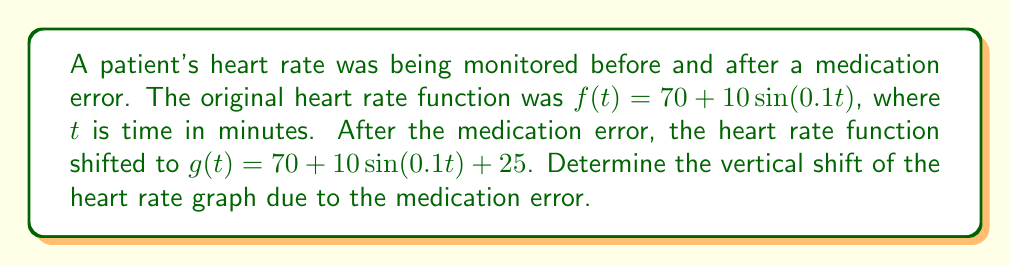What is the answer to this math problem? To find the vertical shift, we need to compare the two functions:

1) Original function: $f(t) = 70 + 10\sin(0.1t)$
2) Shifted function: $g(t) = 70 + 10\sin(0.1t) + 25$

The general form of a vertical shift is:

$g(t) = f(t) + k$

where $k$ is the vertical shift.

Comparing our functions:

$g(t) = [70 + 10\sin(0.1t)] + 25$

We can see that the term inside the brackets is our original function $f(t)$, and it's being shifted up by 25 units.

Therefore, the vertical shift is 25 units upward.

This means that at every point in time, the heart rate after the medication error is 25 beats per minute higher than it would have been without the error, which could be a dangerous situation for the patient.
Answer: 25 units upward 